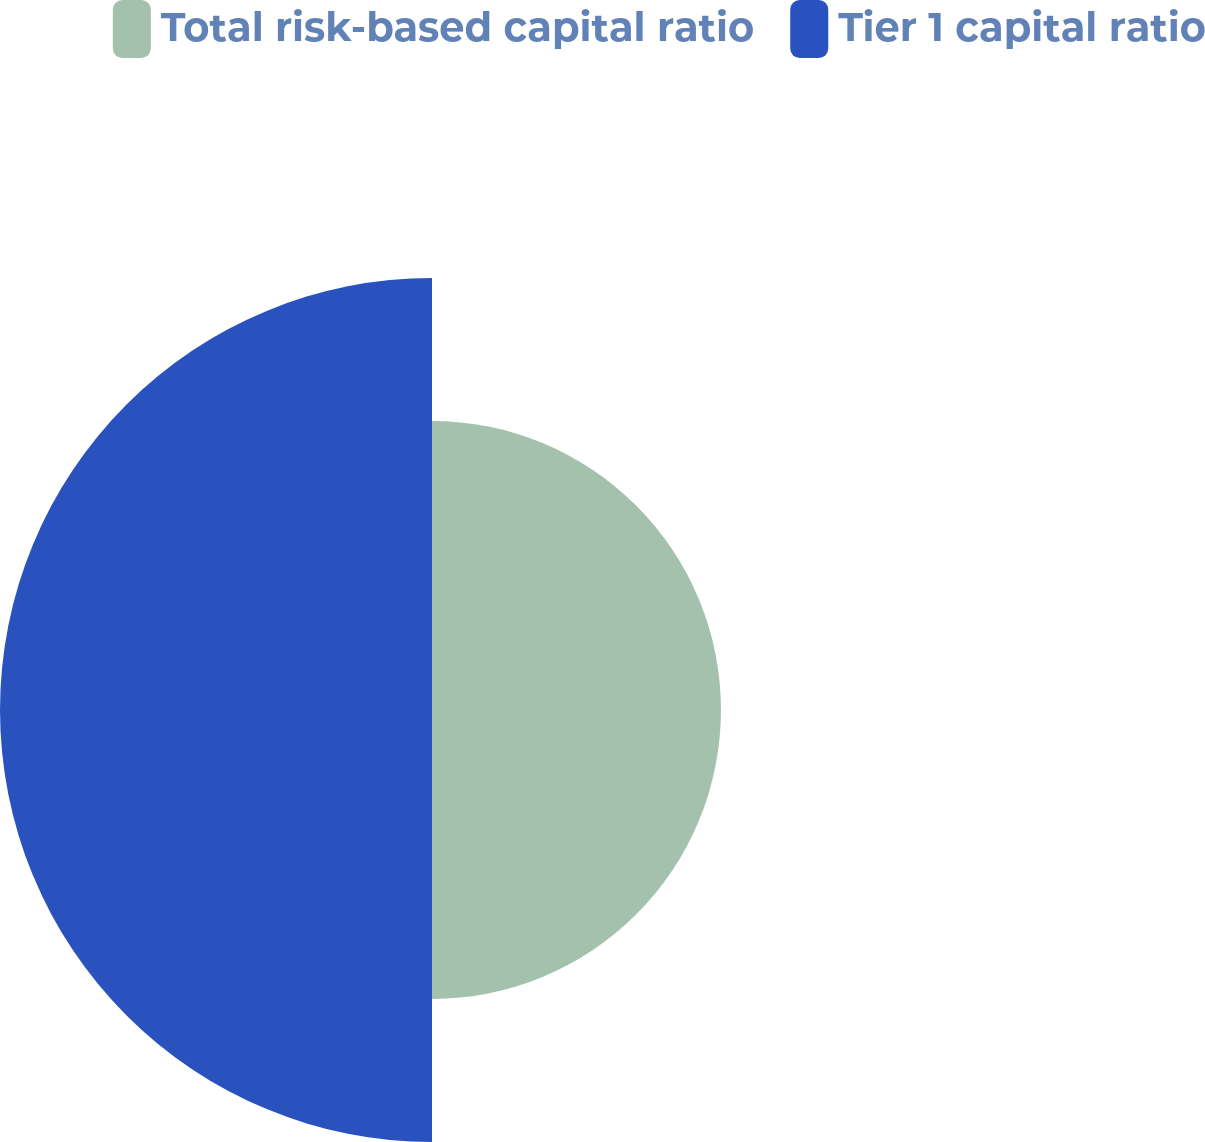<chart> <loc_0><loc_0><loc_500><loc_500><pie_chart><fcel>Total risk-based capital ratio<fcel>Tier 1 capital ratio<nl><fcel>40.08%<fcel>59.92%<nl></chart> 